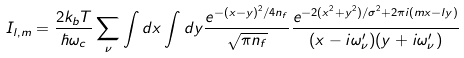<formula> <loc_0><loc_0><loc_500><loc_500>I _ { l , m } = \frac { 2 k _ { b } T } { \hbar { \omega } _ { c } } \sum _ { \nu } \int d x \int d y \frac { e ^ { - ( x - y ) ^ { 2 } / 4 n _ { f } } } { \sqrt { \pi n _ { f } } } \frac { e ^ { - 2 ( x ^ { 2 } + y ^ { 2 } ) / \sigma ^ { 2 } + 2 \pi i ( m x - l y ) } } { ( x - i \omega ^ { \prime } _ { \nu } ) ( y + i \omega ^ { \prime } _ { \nu } ) }</formula> 